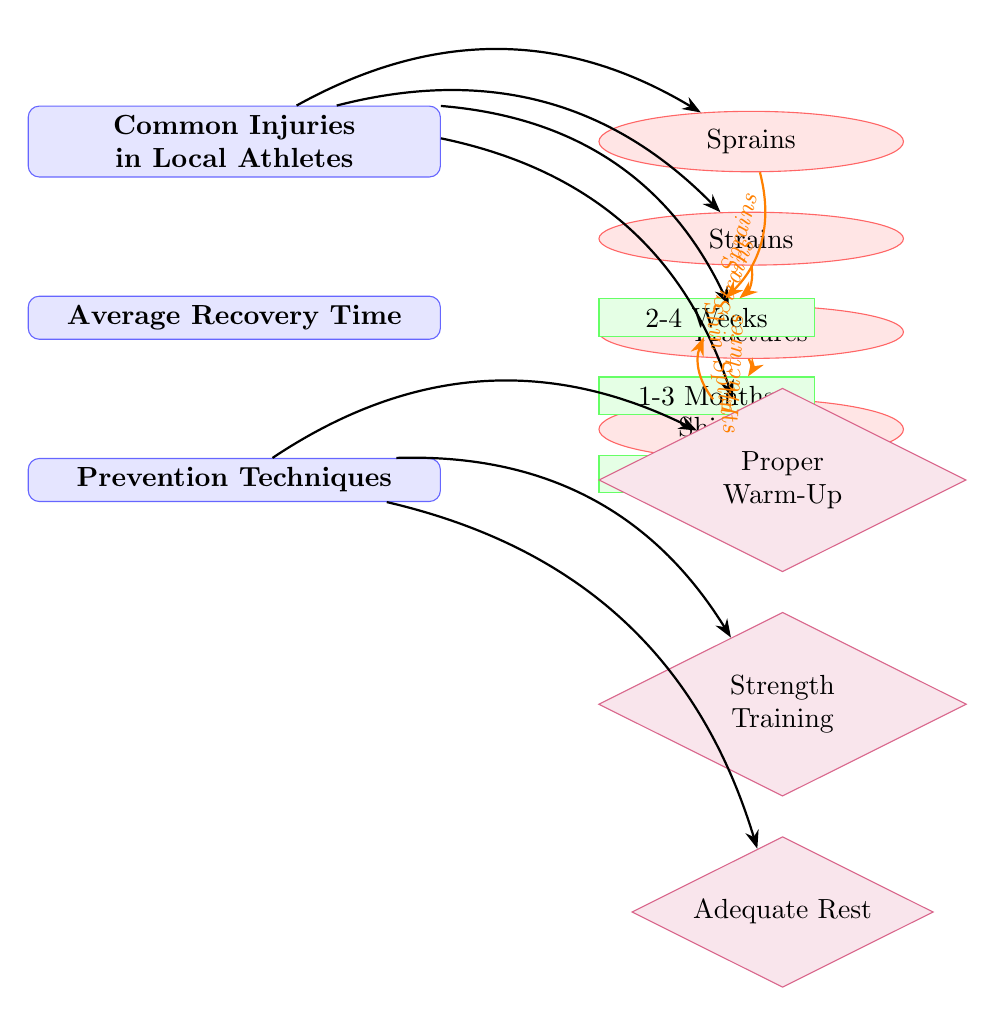What are the common injuries listed in the diagram? The diagram enumerates several common injuries among local athletes. By inspecting the section labeled "Common Injuries in Local Athletes," the injuries listed are sprains, strains, fractures, and shin splints.
Answer: Sprains, strains, fractures, shin splints How many average recovery time categories are there? To find the answer, we need to look under the section labeled "Average Recovery Time." The diagram presents three categories of recovery times: short (2-4 weeks), medium (1-3 months), and long (3-6 months). Therefore, we count these categories.
Answer: Three What is the average recovery time for fractures? The related recovery time for fractures is found in the "Average Recovery Time" section. The arrow from fractures leads to the category labeled "1-3 Months," which signifies the average recovery time. Thus, the recovery time for fractures is 1-3 months.
Answer: 1-3 Months Which prevention technique directly correlates with proper warm-up? In the "Prevention Techniques" section, we need to see which technique is linked to "Proper Warm-Up." The arrow leads from the prevention techniques header to "Proper Warm-Up," which is highlighted as a key technique to prevent injuries. Thus, the answer focuses on proper warm-up itself.
Answer: Proper Warm-Up What is the longest average recovery time listed in the diagram? The "Average Recovery Time" section details the recovery periods. The three options presented, 2-4 weeks, 1-3 months, and 3-6 months indicate that the longest average recovery time is represented by the data point labeled "3-6 Months." Therefore, that is the answer.
Answer: 3-6 Months What are the prevention techniques mentioned in the diagram? The prevention techniques in the diagram can be found under the section labeled "Prevention Techniques." The techniques listed there include "Proper Warm-Up," "Strength Training," and "Adequate Rest." By identifying and citing these three items, we obtain the answer.
Answer: Proper Warm-Up, Strength Training, Adequate Rest 